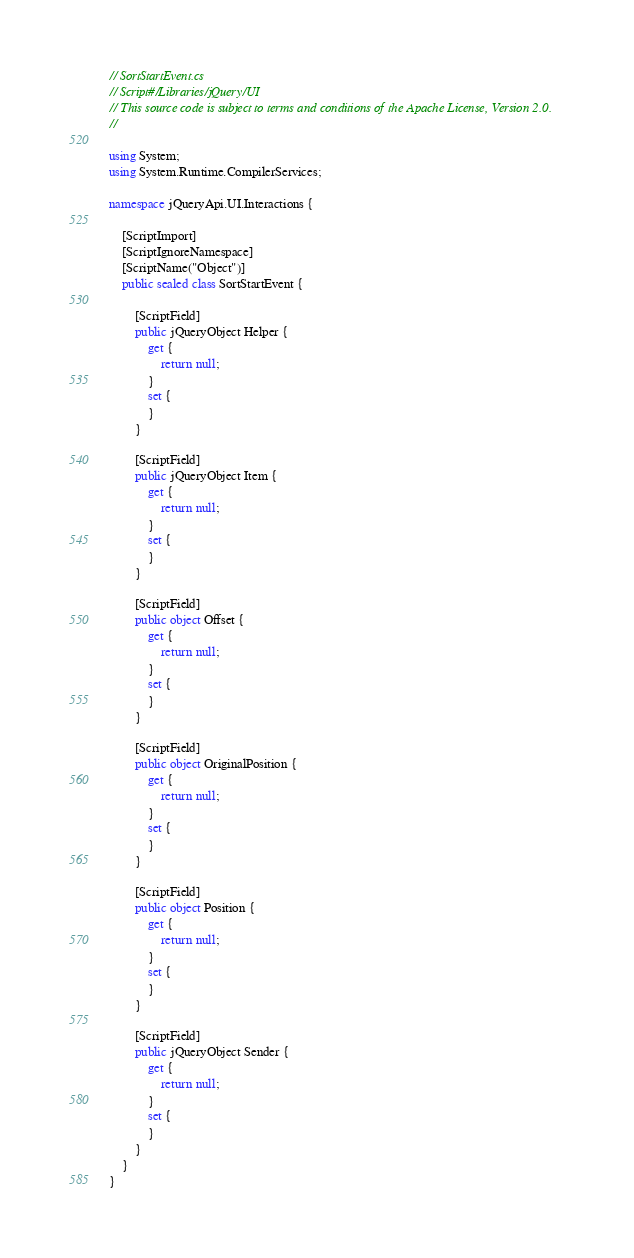<code> <loc_0><loc_0><loc_500><loc_500><_C#_>// SortStartEvent.cs
// Script#/Libraries/jQuery/UI
// This source code is subject to terms and conditions of the Apache License, Version 2.0.
//

using System;
using System.Runtime.CompilerServices;

namespace jQueryApi.UI.Interactions {

    [ScriptImport]
    [ScriptIgnoreNamespace]
    [ScriptName("Object")]
    public sealed class SortStartEvent {

        [ScriptField]
        public jQueryObject Helper {
            get {
                return null;
            }
            set {
            }
        }

        [ScriptField]
        public jQueryObject Item {
            get {
                return null;
            }
            set {
            }
        }

        [ScriptField]
        public object Offset {
            get {
                return null;
            }
            set {
            }
        }

        [ScriptField]
        public object OriginalPosition {
            get {
                return null;
            }
            set {
            }
        }

        [ScriptField]
        public object Position {
            get {
                return null;
            }
            set {
            }
        }

        [ScriptField]
        public jQueryObject Sender {
            get {
                return null;
            }
            set {
            }
        }
    }
}
</code> 